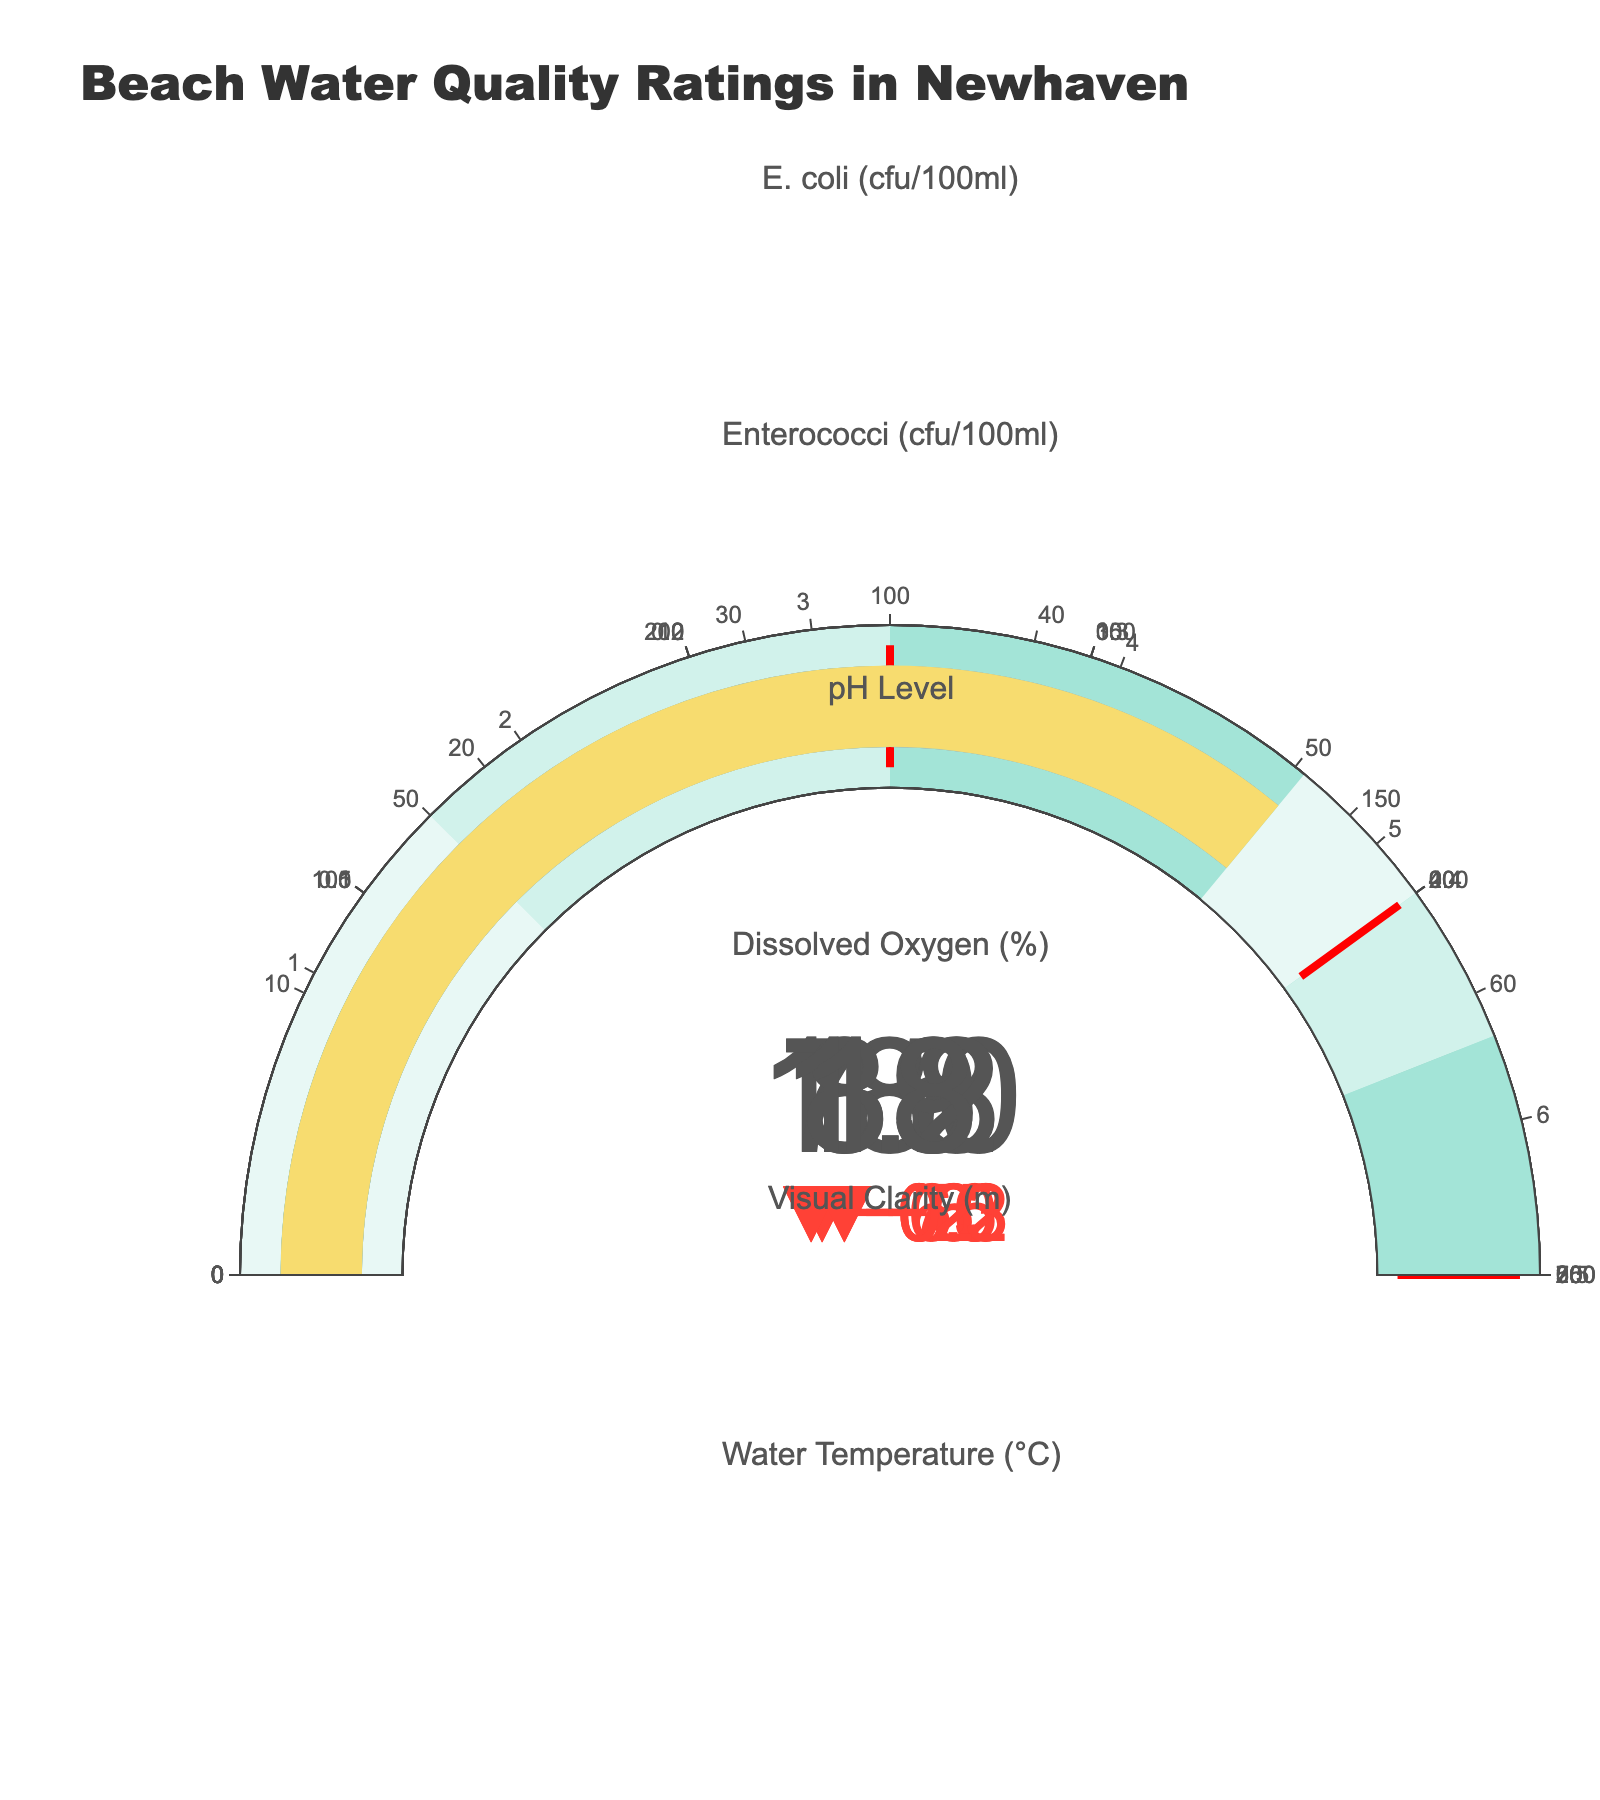What is the title of the chart? The title is typically found at the top of the chart. In this case, it reads "Beach Water Quality Ratings in Newhaven".
Answer: Beach Water Quality Ratings in Newhaven What are the categories evaluated in the bullet chart? Categories are usually listed as subplot titles or on the y-axis in this type of chart. Here, the categories are "E. coli (cfu/100ml)", "Enterococci (cfu/100ml)", "pH Level", "Dissolved Oxygen (%)", "Visual Clarity (m)", and "Water Temperature (°C)".
Answer: E. coli (cfu/100ml), Enterococci (cfu/100ml), pH Level, Dissolved Oxygen (%), Visual Clarity (m), Water Temperature (°C) Which indicator's actual value is furthest below its target value? To determine this, compare the difference between actual and target values for each indicator. For "E. coli (cfu/100ml)" the difference is 70 (250 - 180), for "Enterococci (cfu/100ml)" it is 65 (100 - 35), for "pH Level" it is 0.2 (8.0 - 7.8), for "Dissolved Oxygen (%)" it is 6 (95 - 89), for "Visual Clarity (m)" it is 0.3 (1.5 - 1.2), and for "Water Temperature (°C)" it is 2 (20 - 18). The largest difference is for "E. coli (cfu/100ml)" with a difference of 70.
Answer: E. coli (cfu/100ml) Which indicator scored "Excellent" in the actual evaluation? In the bullet chart, each category has a color-coded segment indicating "Excellent". For "E. coli (cfu/100ml)" the actual value is 180 which is not in the "Excellent" range. Checking each indicator, "Water Temperature (°C)" with an actual value of 18 falls within the "Excellent" range of 18 to 20.
Answer: Water Temperature (°C) Is the pH level within the acceptable range? The acceptable range can be derived from the poor to excellent ranges for pH levels (6.5-8.0). The actual pH level is 7.8, which falls within this range.
Answer: Yes How many indicators meet or exceed their target values? Examining each category one-by-one: "E. coli (cfu/100ml)" at 180 is less than 250, "Enterococci (cfu/100ml)" at 35 is less than 100, "pH Level" at 7.8 is less than 8.0, "Dissolved Oxygen (%)" at 89 is less than 95, "Visual Clarity (m)" at 1.2 is less than 1.5, and "Water Temperature (°C)" at 18 meets the target of 18. Only "Water Temperature (°C)" meets or exceeds its target.
Answer: 1 Is there any indicator where the actual value is in the "Poor" range? The "Poor" range is marked by the lower bound of each indicator's value scale. Checking each: "E. coli (cfu/100ml)" actual is 180 (Poor > 500), "Enterococci (cfu/100ml)" actual is 35 (Poor > 200), "pH Level" actual is 7.8 (Poor < 6.5), "Dissolved Oxygen (%)" actual is 89 (Poor < 70), "Visual Clarity (m)" actual is 1.2 (Poor < 0.5), "Water Temperature (°C)" actual is 18 (Poor > 25). None of the actual values fall in the "Poor" range.
Answer: No 